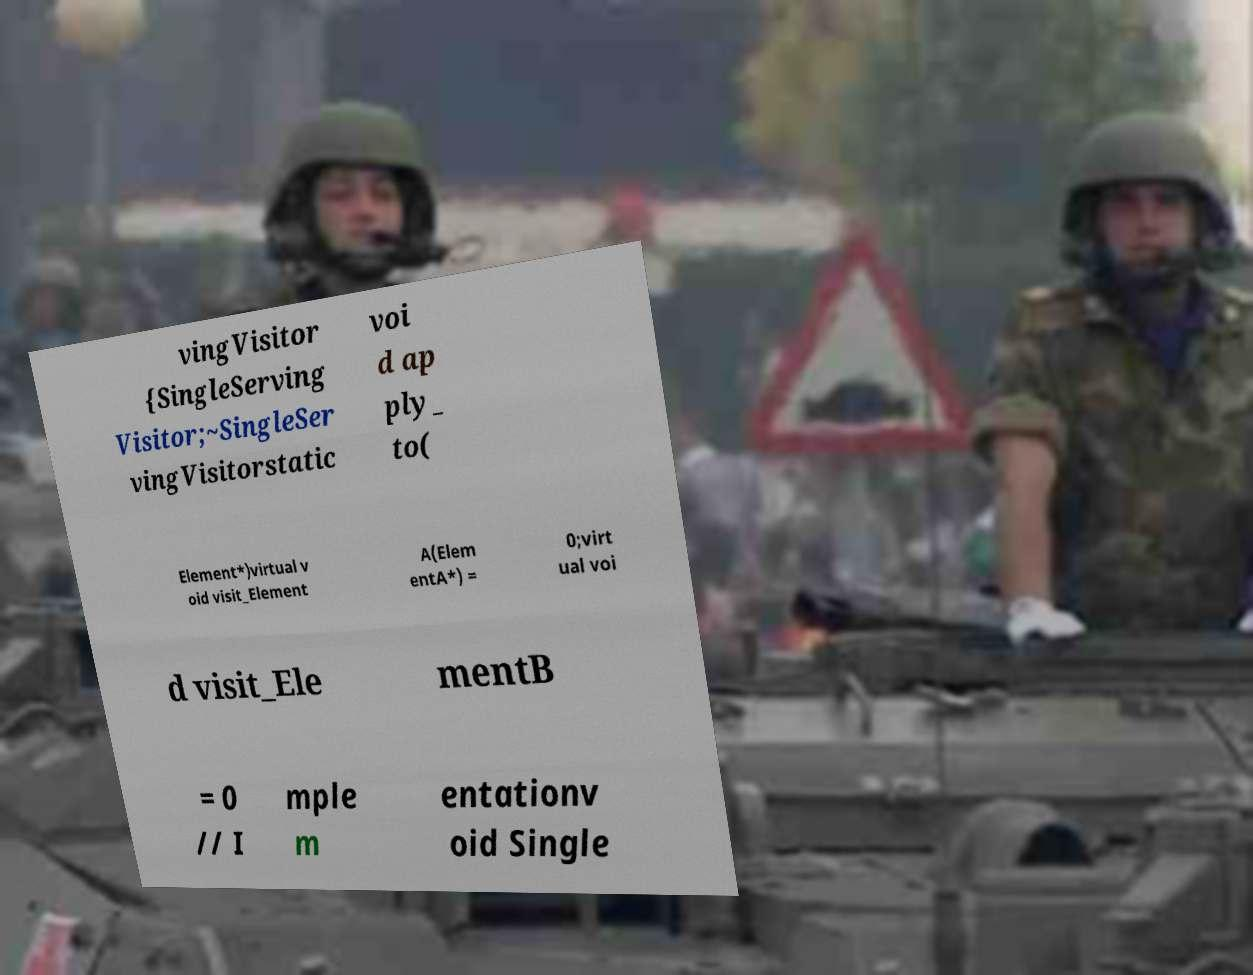Can you read and provide the text displayed in the image?This photo seems to have some interesting text. Can you extract and type it out for me? vingVisitor {SingleServing Visitor;~SingleSer vingVisitorstatic voi d ap ply_ to( Element*)virtual v oid visit_Element A(Elem entA*) = 0;virt ual voi d visit_Ele mentB = 0 // I mple m entationv oid Single 